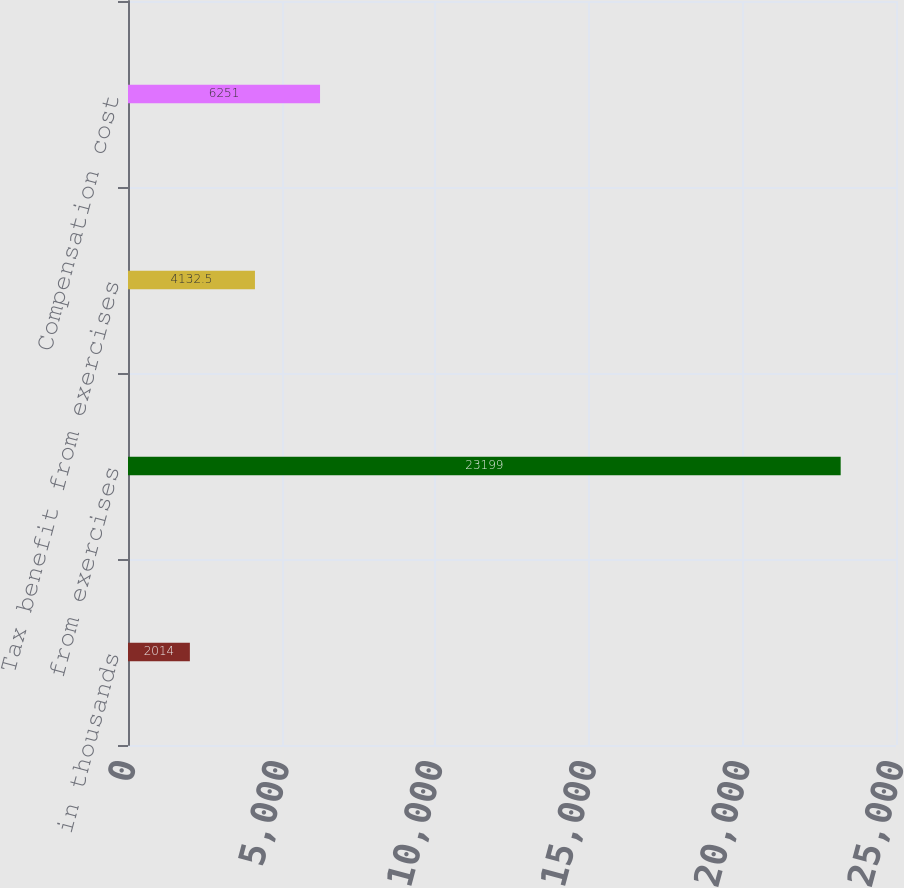<chart> <loc_0><loc_0><loc_500><loc_500><bar_chart><fcel>in thousands<fcel>from exercises<fcel>Tax benefit from exercises<fcel>Compensation cost<nl><fcel>2014<fcel>23199<fcel>4132.5<fcel>6251<nl></chart> 